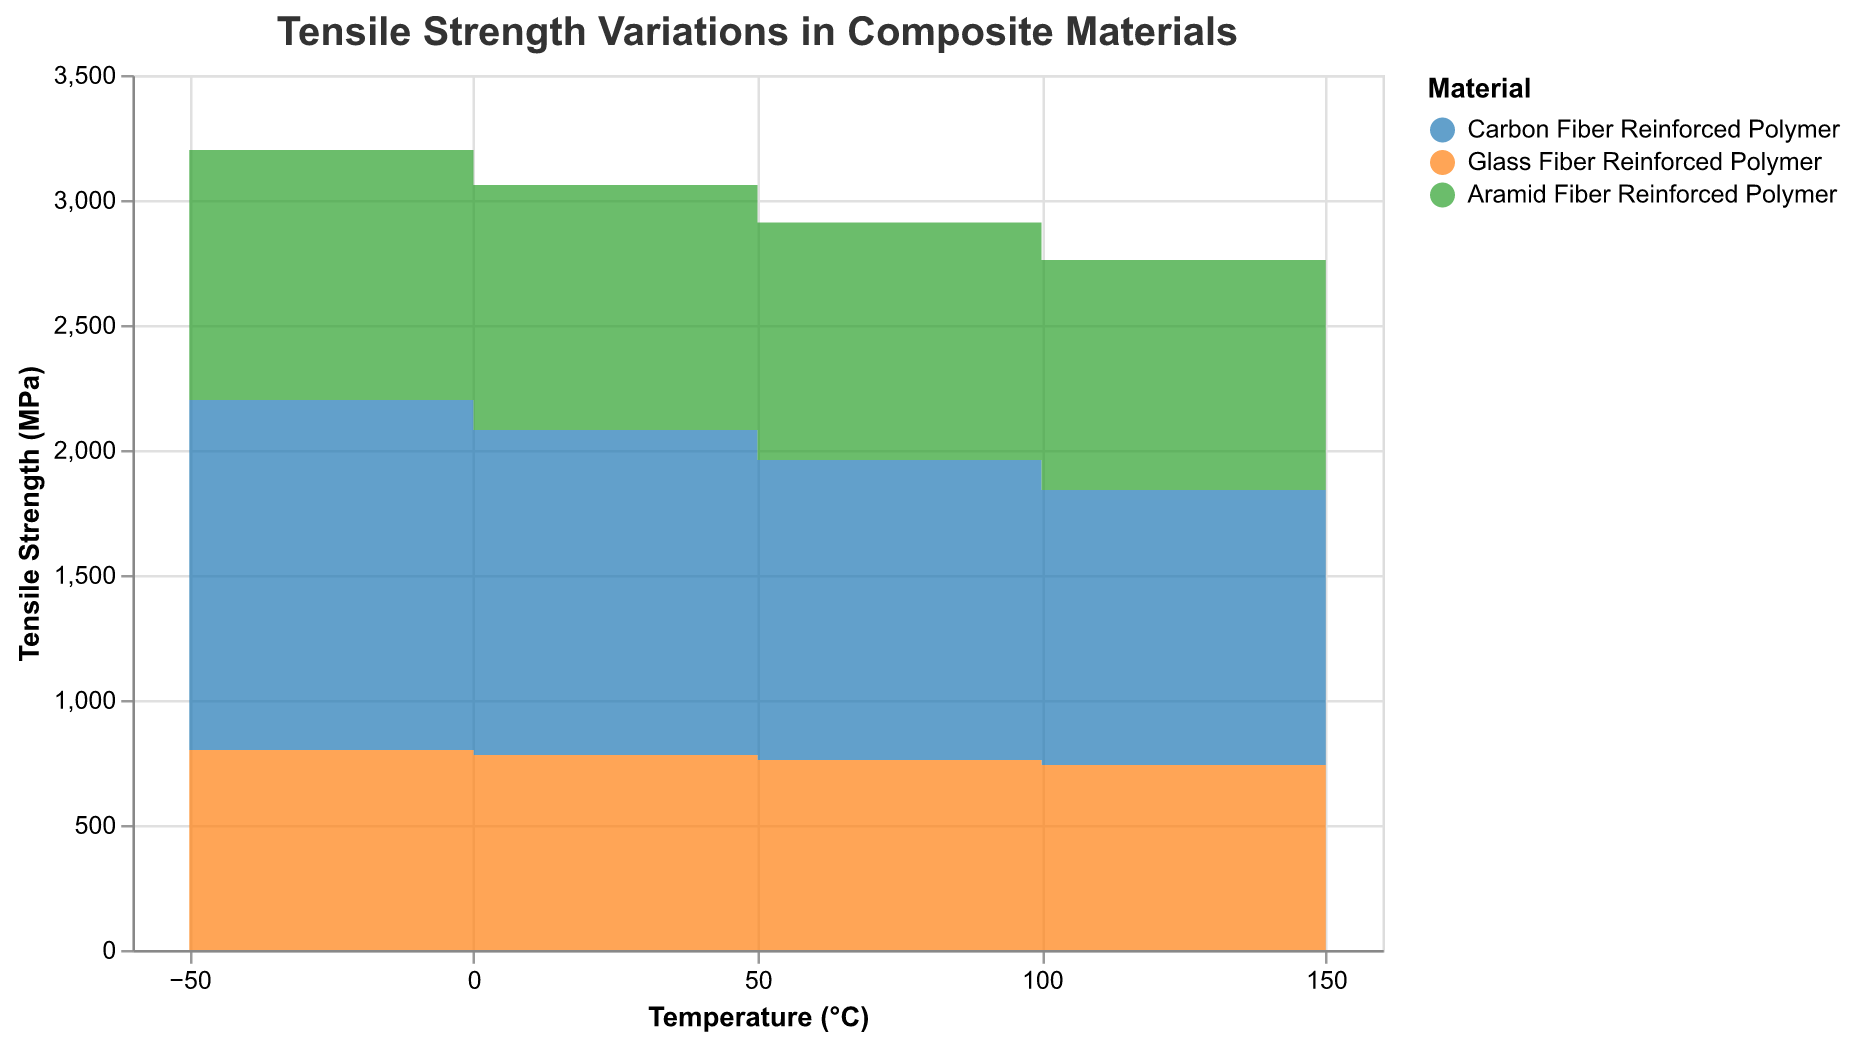What's the title of the chart? The title is displayed at the top of the chart. It helps in identifying the topic being visualized.
Answer: Tensile Strength Variations in Composite Materials What temperature range is covered in the chart? The x-axis shows the temperature (°C) with tick marks indicating specific values. The range can be determined from the smallest to the largest temperature values.
Answer: -50°C to 150°C How many materials are compared in the chart? The legend next to the chart indicates the different materials.
Answer: 3 Which material has the highest tensile strength at -50°C? By looking at the starting point of each step area plot at -50°C on the x-axis, the y-values indicate the tensile strength.
Answer: Carbon Fiber Reinforced Polymer How does the tensile strength of Glass Fiber Reinforced Polymer change as the temperature increases from -50°C to 150°C? Follow the step area plot corresponding to the Glass Fiber Reinforced Polymer from -50°C to 150°C. The y-value indicates the tensile strength.
Answer: Decreases from 800 MPa to 720 MPa What is the change in tensile strength of Aramid Fiber Reinforced Polymer from -50°C to 150°C? Find the tensile strength values of Aramid Fiber Reinforced Polymer at -50°C and 150°C, then subtract the latter from the former.
Answer: 1000 MPa - 880 MPa = 120 MPa Which material experiences the most significant decrease in tensile strength over the given temperature range? Calculate the tensile strength decrease for each material by subtracting the final value from the initial value, then compare them.
Answer: Carbon Fiber Reinforced Polymer decreases by 400 MPa, Glass Fiber Reinforced Polymer by 80 MPa, and Aramid Fiber Reinforced Polymer by 120 MPa. Carbon Fiber Reinforced Polymer has the most significant decrease At what temperature do the tensile strengths of Carbon Fiber Reinforced Polymer and Aramid Fiber Reinforced Polymer converge? Identify the temperature where the step area plots for Carbon Fiber Reinforced Polymer and Aramid Fiber Reinforced Polymer show the same y-value.
Answer: They do not converge at any temperature within the given range Compare the tensile strength value of Carbon Fiber Reinforced Polymer at 0°C to Glass Fiber Reinforced Polymer at 100°C. Find the tensile strength values for the specified materials at the given temperatures on the step area plots and compare them.
Answer: 1300 MPa (Carbon at 0°C) vs. 740 MPa (Glass at 100°C) How much higher is the tensile strength of Carbon Fiber Reinforced Polymer at 50°C compared to Glass Fiber Reinforced Polymer at the same temperature? Locate the tensile strength for both materials at 50°C, then subtract the value of Glass Fiber Reinforced Polymer from Carbon Fiber Reinforced Polymer.
Answer: 1200 MPa - 760 MPa = 440 MPa 